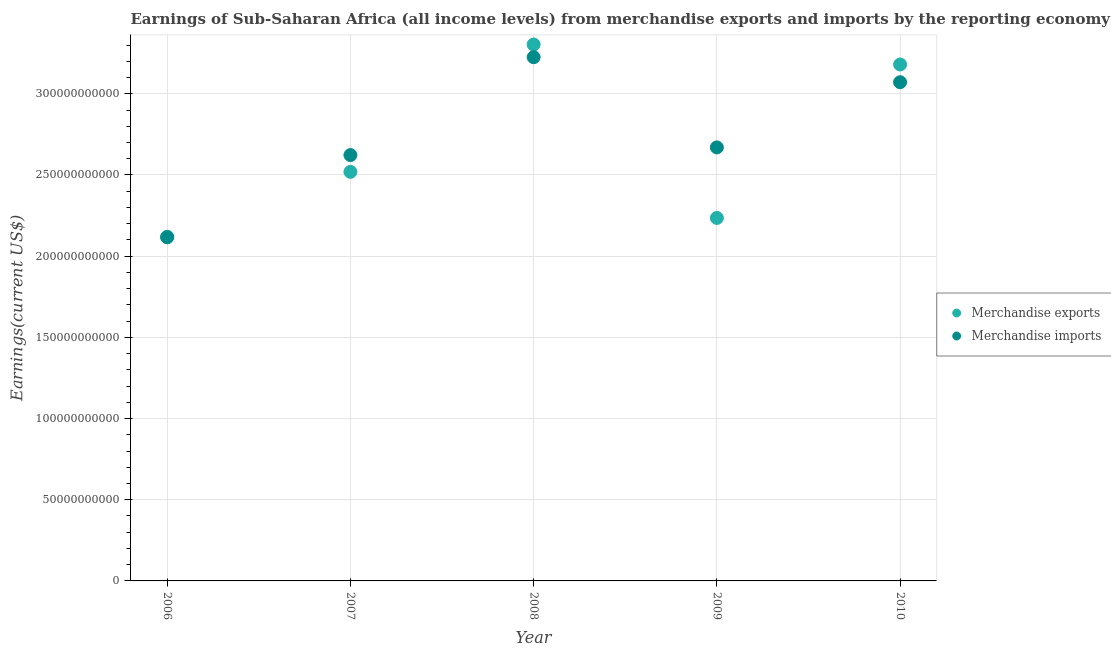How many different coloured dotlines are there?
Your answer should be compact. 2. Is the number of dotlines equal to the number of legend labels?
Give a very brief answer. Yes. What is the earnings from merchandise imports in 2008?
Provide a short and direct response. 3.23e+11. Across all years, what is the maximum earnings from merchandise exports?
Offer a terse response. 3.30e+11. Across all years, what is the minimum earnings from merchandise imports?
Offer a terse response. 2.12e+11. In which year was the earnings from merchandise exports maximum?
Offer a terse response. 2008. What is the total earnings from merchandise exports in the graph?
Provide a short and direct response. 1.34e+12. What is the difference between the earnings from merchandise imports in 2007 and that in 2008?
Provide a short and direct response. -6.03e+1. What is the difference between the earnings from merchandise exports in 2009 and the earnings from merchandise imports in 2008?
Your answer should be compact. -9.90e+1. What is the average earnings from merchandise exports per year?
Provide a succinct answer. 2.67e+11. In the year 2009, what is the difference between the earnings from merchandise imports and earnings from merchandise exports?
Offer a terse response. 4.34e+1. What is the ratio of the earnings from merchandise imports in 2009 to that in 2010?
Give a very brief answer. 0.87. Is the earnings from merchandise exports in 2007 less than that in 2008?
Ensure brevity in your answer.  Yes. Is the difference between the earnings from merchandise imports in 2008 and 2009 greater than the difference between the earnings from merchandise exports in 2008 and 2009?
Your answer should be compact. No. What is the difference between the highest and the second highest earnings from merchandise exports?
Your response must be concise. 1.23e+1. What is the difference between the highest and the lowest earnings from merchandise imports?
Your response must be concise. 1.11e+11. Is the sum of the earnings from merchandise imports in 2006 and 2010 greater than the maximum earnings from merchandise exports across all years?
Give a very brief answer. Yes. Does the earnings from merchandise exports monotonically increase over the years?
Offer a very short reply. No. Is the earnings from merchandise imports strictly greater than the earnings from merchandise exports over the years?
Offer a terse response. No. Is the earnings from merchandise exports strictly less than the earnings from merchandise imports over the years?
Your answer should be very brief. No. How many years are there in the graph?
Your answer should be very brief. 5. What is the difference between two consecutive major ticks on the Y-axis?
Offer a terse response. 5.00e+1. Are the values on the major ticks of Y-axis written in scientific E-notation?
Keep it short and to the point. No. Does the graph contain any zero values?
Keep it short and to the point. No. How many legend labels are there?
Your response must be concise. 2. What is the title of the graph?
Keep it short and to the point. Earnings of Sub-Saharan Africa (all income levels) from merchandise exports and imports by the reporting economy. Does "Diarrhea" appear as one of the legend labels in the graph?
Provide a short and direct response. No. What is the label or title of the Y-axis?
Ensure brevity in your answer.  Earnings(current US$). What is the Earnings(current US$) in Merchandise exports in 2006?
Provide a short and direct response. 2.12e+11. What is the Earnings(current US$) of Merchandise imports in 2006?
Provide a succinct answer. 2.12e+11. What is the Earnings(current US$) of Merchandise exports in 2007?
Your answer should be compact. 2.52e+11. What is the Earnings(current US$) in Merchandise imports in 2007?
Offer a very short reply. 2.62e+11. What is the Earnings(current US$) of Merchandise exports in 2008?
Offer a terse response. 3.30e+11. What is the Earnings(current US$) in Merchandise imports in 2008?
Your answer should be compact. 3.23e+11. What is the Earnings(current US$) of Merchandise exports in 2009?
Offer a very short reply. 2.24e+11. What is the Earnings(current US$) of Merchandise imports in 2009?
Your answer should be compact. 2.67e+11. What is the Earnings(current US$) in Merchandise exports in 2010?
Keep it short and to the point. 3.18e+11. What is the Earnings(current US$) of Merchandise imports in 2010?
Provide a succinct answer. 3.07e+11. Across all years, what is the maximum Earnings(current US$) in Merchandise exports?
Provide a short and direct response. 3.30e+11. Across all years, what is the maximum Earnings(current US$) of Merchandise imports?
Your response must be concise. 3.23e+11. Across all years, what is the minimum Earnings(current US$) of Merchandise exports?
Keep it short and to the point. 2.12e+11. Across all years, what is the minimum Earnings(current US$) of Merchandise imports?
Give a very brief answer. 2.12e+11. What is the total Earnings(current US$) of Merchandise exports in the graph?
Keep it short and to the point. 1.34e+12. What is the total Earnings(current US$) in Merchandise imports in the graph?
Offer a very short reply. 1.37e+12. What is the difference between the Earnings(current US$) in Merchandise exports in 2006 and that in 2007?
Provide a short and direct response. -4.00e+1. What is the difference between the Earnings(current US$) of Merchandise imports in 2006 and that in 2007?
Give a very brief answer. -5.06e+1. What is the difference between the Earnings(current US$) in Merchandise exports in 2006 and that in 2008?
Provide a short and direct response. -1.18e+11. What is the difference between the Earnings(current US$) of Merchandise imports in 2006 and that in 2008?
Provide a short and direct response. -1.11e+11. What is the difference between the Earnings(current US$) of Merchandise exports in 2006 and that in 2009?
Give a very brief answer. -1.16e+1. What is the difference between the Earnings(current US$) in Merchandise imports in 2006 and that in 2009?
Make the answer very short. -5.54e+1. What is the difference between the Earnings(current US$) of Merchandise exports in 2006 and that in 2010?
Provide a short and direct response. -1.06e+11. What is the difference between the Earnings(current US$) of Merchandise imports in 2006 and that in 2010?
Make the answer very short. -9.55e+1. What is the difference between the Earnings(current US$) in Merchandise exports in 2007 and that in 2008?
Your answer should be very brief. -7.84e+1. What is the difference between the Earnings(current US$) of Merchandise imports in 2007 and that in 2008?
Your answer should be compact. -6.03e+1. What is the difference between the Earnings(current US$) in Merchandise exports in 2007 and that in 2009?
Provide a short and direct response. 2.84e+1. What is the difference between the Earnings(current US$) of Merchandise imports in 2007 and that in 2009?
Offer a very short reply. -4.73e+09. What is the difference between the Earnings(current US$) in Merchandise exports in 2007 and that in 2010?
Your response must be concise. -6.61e+1. What is the difference between the Earnings(current US$) in Merchandise imports in 2007 and that in 2010?
Give a very brief answer. -4.49e+1. What is the difference between the Earnings(current US$) in Merchandise exports in 2008 and that in 2009?
Make the answer very short. 1.07e+11. What is the difference between the Earnings(current US$) in Merchandise imports in 2008 and that in 2009?
Make the answer very short. 5.56e+1. What is the difference between the Earnings(current US$) in Merchandise exports in 2008 and that in 2010?
Make the answer very short. 1.23e+1. What is the difference between the Earnings(current US$) of Merchandise imports in 2008 and that in 2010?
Ensure brevity in your answer.  1.54e+1. What is the difference between the Earnings(current US$) in Merchandise exports in 2009 and that in 2010?
Offer a terse response. -9.45e+1. What is the difference between the Earnings(current US$) of Merchandise imports in 2009 and that in 2010?
Your answer should be very brief. -4.02e+1. What is the difference between the Earnings(current US$) in Merchandise exports in 2006 and the Earnings(current US$) in Merchandise imports in 2007?
Offer a very short reply. -5.03e+1. What is the difference between the Earnings(current US$) in Merchandise exports in 2006 and the Earnings(current US$) in Merchandise imports in 2008?
Give a very brief answer. -1.11e+11. What is the difference between the Earnings(current US$) in Merchandise exports in 2006 and the Earnings(current US$) in Merchandise imports in 2009?
Provide a short and direct response. -5.50e+1. What is the difference between the Earnings(current US$) in Merchandise exports in 2006 and the Earnings(current US$) in Merchandise imports in 2010?
Keep it short and to the point. -9.52e+1. What is the difference between the Earnings(current US$) of Merchandise exports in 2007 and the Earnings(current US$) of Merchandise imports in 2008?
Provide a short and direct response. -7.06e+1. What is the difference between the Earnings(current US$) in Merchandise exports in 2007 and the Earnings(current US$) in Merchandise imports in 2009?
Offer a terse response. -1.50e+1. What is the difference between the Earnings(current US$) in Merchandise exports in 2007 and the Earnings(current US$) in Merchandise imports in 2010?
Offer a terse response. -5.52e+1. What is the difference between the Earnings(current US$) in Merchandise exports in 2008 and the Earnings(current US$) in Merchandise imports in 2009?
Your answer should be compact. 6.34e+1. What is the difference between the Earnings(current US$) of Merchandise exports in 2008 and the Earnings(current US$) of Merchandise imports in 2010?
Offer a terse response. 2.32e+1. What is the difference between the Earnings(current US$) in Merchandise exports in 2009 and the Earnings(current US$) in Merchandise imports in 2010?
Make the answer very short. -8.36e+1. What is the average Earnings(current US$) of Merchandise exports per year?
Your response must be concise. 2.67e+11. What is the average Earnings(current US$) of Merchandise imports per year?
Offer a very short reply. 2.74e+11. In the year 2006, what is the difference between the Earnings(current US$) of Merchandise exports and Earnings(current US$) of Merchandise imports?
Your answer should be compact. 3.49e+08. In the year 2007, what is the difference between the Earnings(current US$) in Merchandise exports and Earnings(current US$) in Merchandise imports?
Your answer should be very brief. -1.03e+1. In the year 2008, what is the difference between the Earnings(current US$) of Merchandise exports and Earnings(current US$) of Merchandise imports?
Offer a very short reply. 7.80e+09. In the year 2009, what is the difference between the Earnings(current US$) of Merchandise exports and Earnings(current US$) of Merchandise imports?
Give a very brief answer. -4.34e+1. In the year 2010, what is the difference between the Earnings(current US$) of Merchandise exports and Earnings(current US$) of Merchandise imports?
Your answer should be compact. 1.09e+1. What is the ratio of the Earnings(current US$) in Merchandise exports in 2006 to that in 2007?
Your answer should be very brief. 0.84. What is the ratio of the Earnings(current US$) in Merchandise imports in 2006 to that in 2007?
Your answer should be compact. 0.81. What is the ratio of the Earnings(current US$) in Merchandise exports in 2006 to that in 2008?
Provide a succinct answer. 0.64. What is the ratio of the Earnings(current US$) of Merchandise imports in 2006 to that in 2008?
Offer a very short reply. 0.66. What is the ratio of the Earnings(current US$) in Merchandise exports in 2006 to that in 2009?
Give a very brief answer. 0.95. What is the ratio of the Earnings(current US$) in Merchandise imports in 2006 to that in 2009?
Provide a short and direct response. 0.79. What is the ratio of the Earnings(current US$) of Merchandise exports in 2006 to that in 2010?
Provide a short and direct response. 0.67. What is the ratio of the Earnings(current US$) of Merchandise imports in 2006 to that in 2010?
Offer a terse response. 0.69. What is the ratio of the Earnings(current US$) of Merchandise exports in 2007 to that in 2008?
Make the answer very short. 0.76. What is the ratio of the Earnings(current US$) of Merchandise imports in 2007 to that in 2008?
Make the answer very short. 0.81. What is the ratio of the Earnings(current US$) of Merchandise exports in 2007 to that in 2009?
Provide a succinct answer. 1.13. What is the ratio of the Earnings(current US$) of Merchandise imports in 2007 to that in 2009?
Ensure brevity in your answer.  0.98. What is the ratio of the Earnings(current US$) in Merchandise exports in 2007 to that in 2010?
Provide a short and direct response. 0.79. What is the ratio of the Earnings(current US$) in Merchandise imports in 2007 to that in 2010?
Ensure brevity in your answer.  0.85. What is the ratio of the Earnings(current US$) in Merchandise exports in 2008 to that in 2009?
Offer a terse response. 1.48. What is the ratio of the Earnings(current US$) in Merchandise imports in 2008 to that in 2009?
Give a very brief answer. 1.21. What is the ratio of the Earnings(current US$) in Merchandise exports in 2008 to that in 2010?
Give a very brief answer. 1.04. What is the ratio of the Earnings(current US$) of Merchandise imports in 2008 to that in 2010?
Your answer should be compact. 1.05. What is the ratio of the Earnings(current US$) in Merchandise exports in 2009 to that in 2010?
Offer a terse response. 0.7. What is the ratio of the Earnings(current US$) of Merchandise imports in 2009 to that in 2010?
Provide a short and direct response. 0.87. What is the difference between the highest and the second highest Earnings(current US$) in Merchandise exports?
Ensure brevity in your answer.  1.23e+1. What is the difference between the highest and the second highest Earnings(current US$) in Merchandise imports?
Your answer should be very brief. 1.54e+1. What is the difference between the highest and the lowest Earnings(current US$) in Merchandise exports?
Give a very brief answer. 1.18e+11. What is the difference between the highest and the lowest Earnings(current US$) of Merchandise imports?
Your answer should be compact. 1.11e+11. 